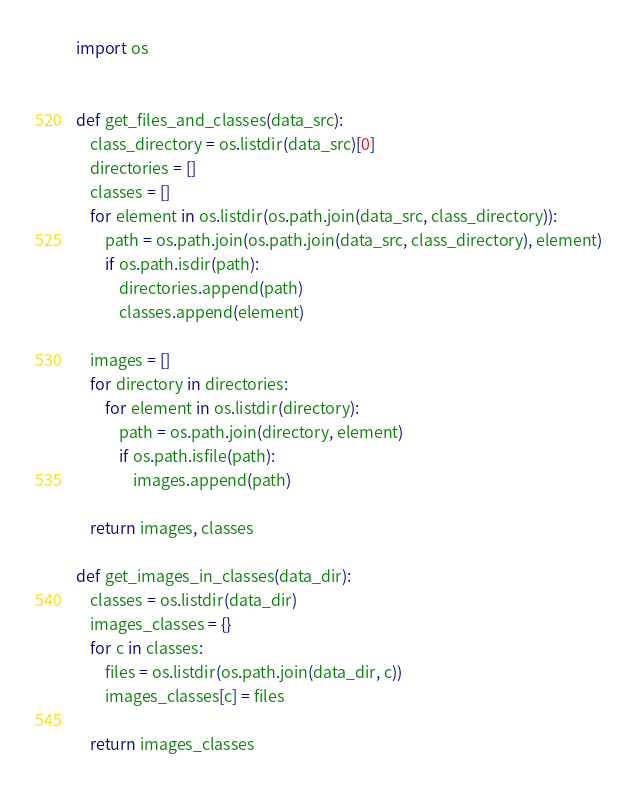<code> <loc_0><loc_0><loc_500><loc_500><_Python_>import os


def get_files_and_classes(data_src):
    class_directory = os.listdir(data_src)[0]
    directories = []
    classes = []
    for element in os.listdir(os.path.join(data_src, class_directory)):
        path = os.path.join(os.path.join(data_src, class_directory), element)
        if os.path.isdir(path):
            directories.append(path)
            classes.append(element)

    images = []
    for directory in directories:
        for element in os.listdir(directory):
            path = os.path.join(directory, element)
            if os.path.isfile(path):
                images.append(path)

    return images, classes

def get_images_in_classes(data_dir):
    classes = os.listdir(data_dir)
    images_classes = {}
    for c in classes:
        files = os.listdir(os.path.join(data_dir, c))
        images_classes[c] = files

    return images_classes</code> 